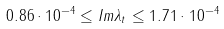<formula> <loc_0><loc_0><loc_500><loc_500>0 . 8 6 \cdot 1 0 ^ { - 4 } \leq I m \lambda _ { t } \leq 1 . 7 1 \cdot 1 0 ^ { - 4 }</formula> 